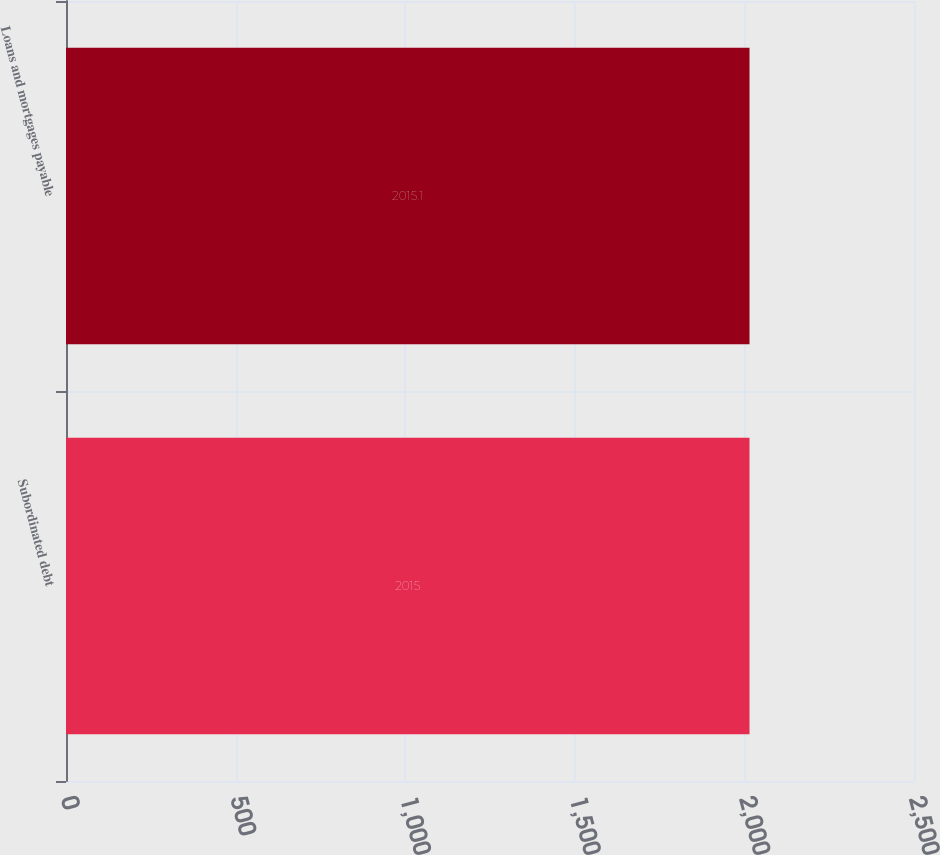Convert chart to OTSL. <chart><loc_0><loc_0><loc_500><loc_500><bar_chart><fcel>Subordinated debt<fcel>Loans and mortgages payable<nl><fcel>2015<fcel>2015.1<nl></chart> 